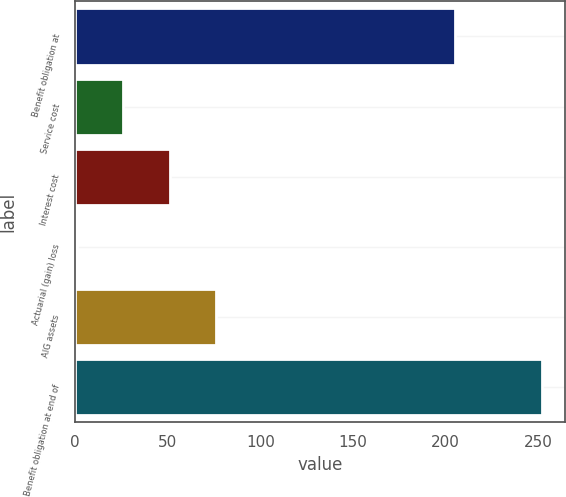Convert chart. <chart><loc_0><loc_0><loc_500><loc_500><bar_chart><fcel>Benefit obligation at<fcel>Service cost<fcel>Interest cost<fcel>Actuarial (gain) loss<fcel>AIG assets<fcel>Benefit obligation at end of<nl><fcel>205<fcel>26.1<fcel>51.2<fcel>1<fcel>76.3<fcel>252<nl></chart> 